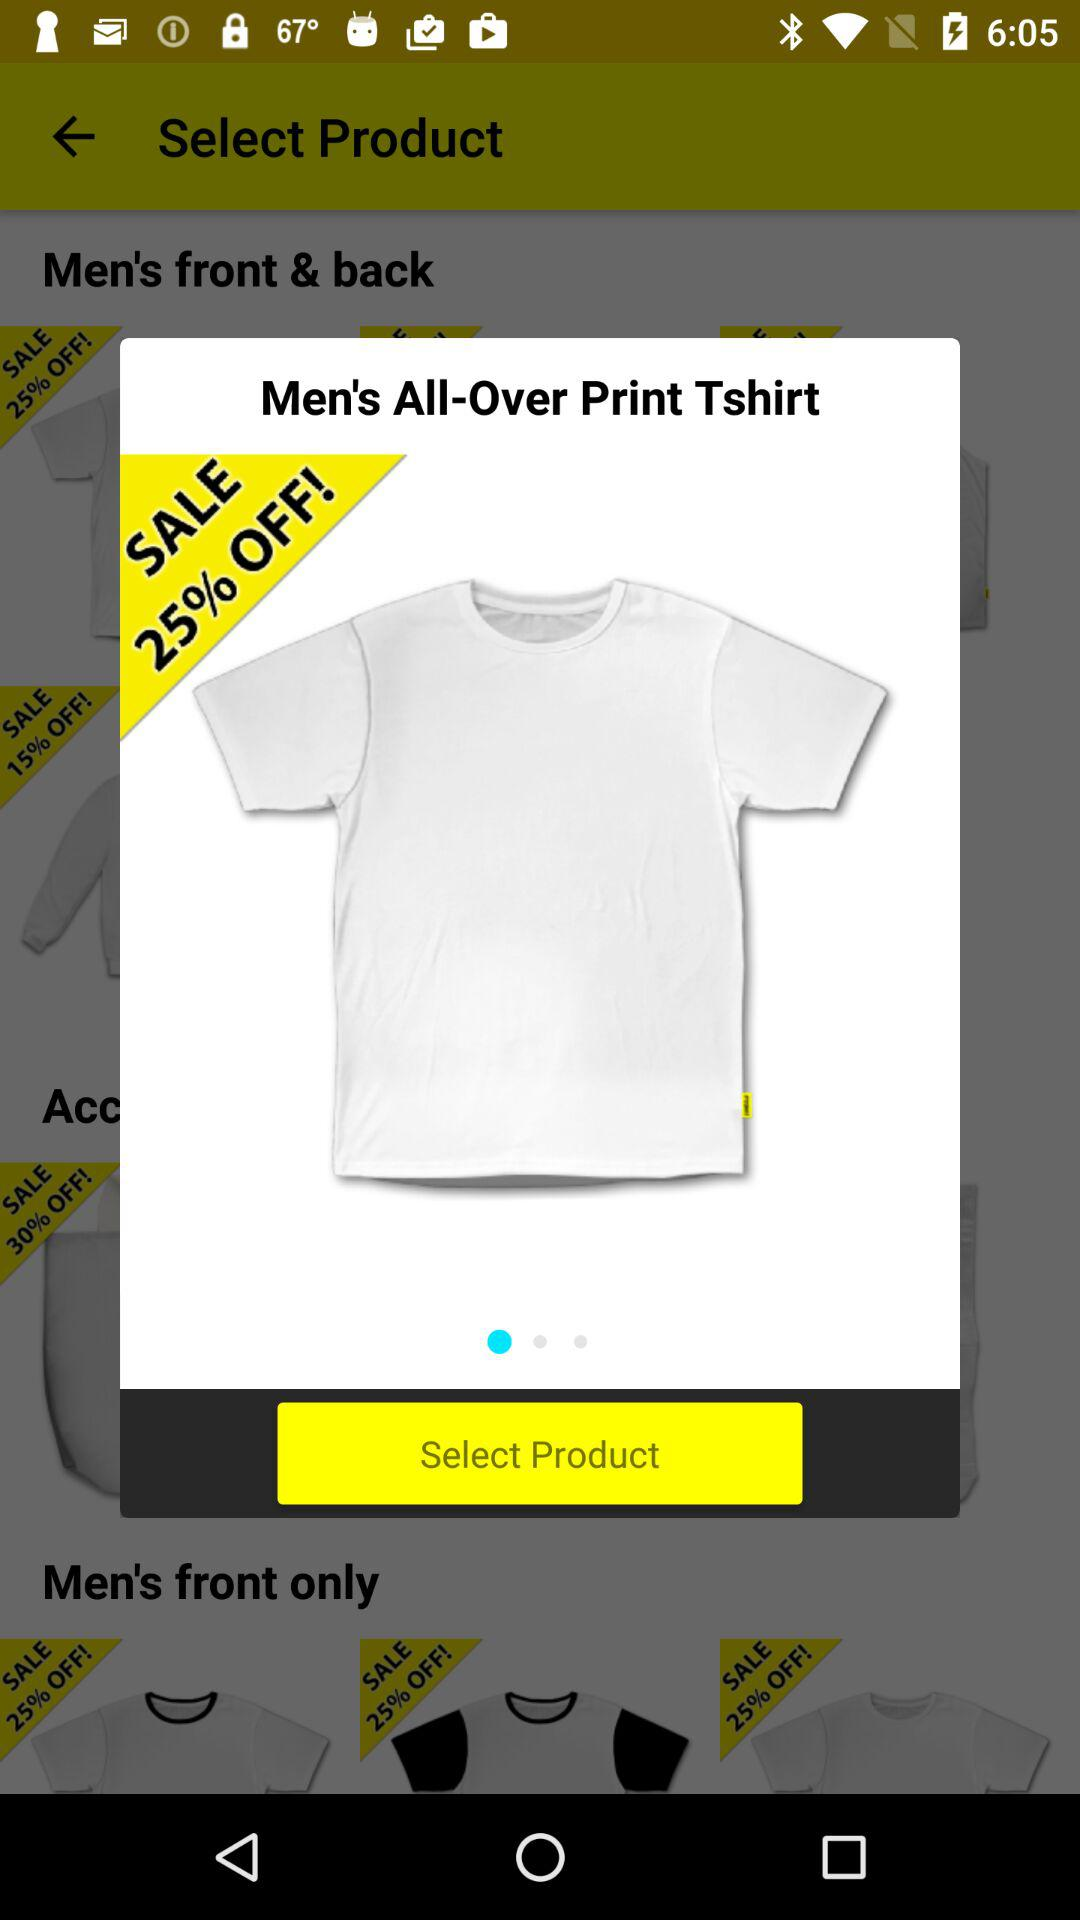How much is the discount on the product?
Answer the question using a single word or phrase. 25% 